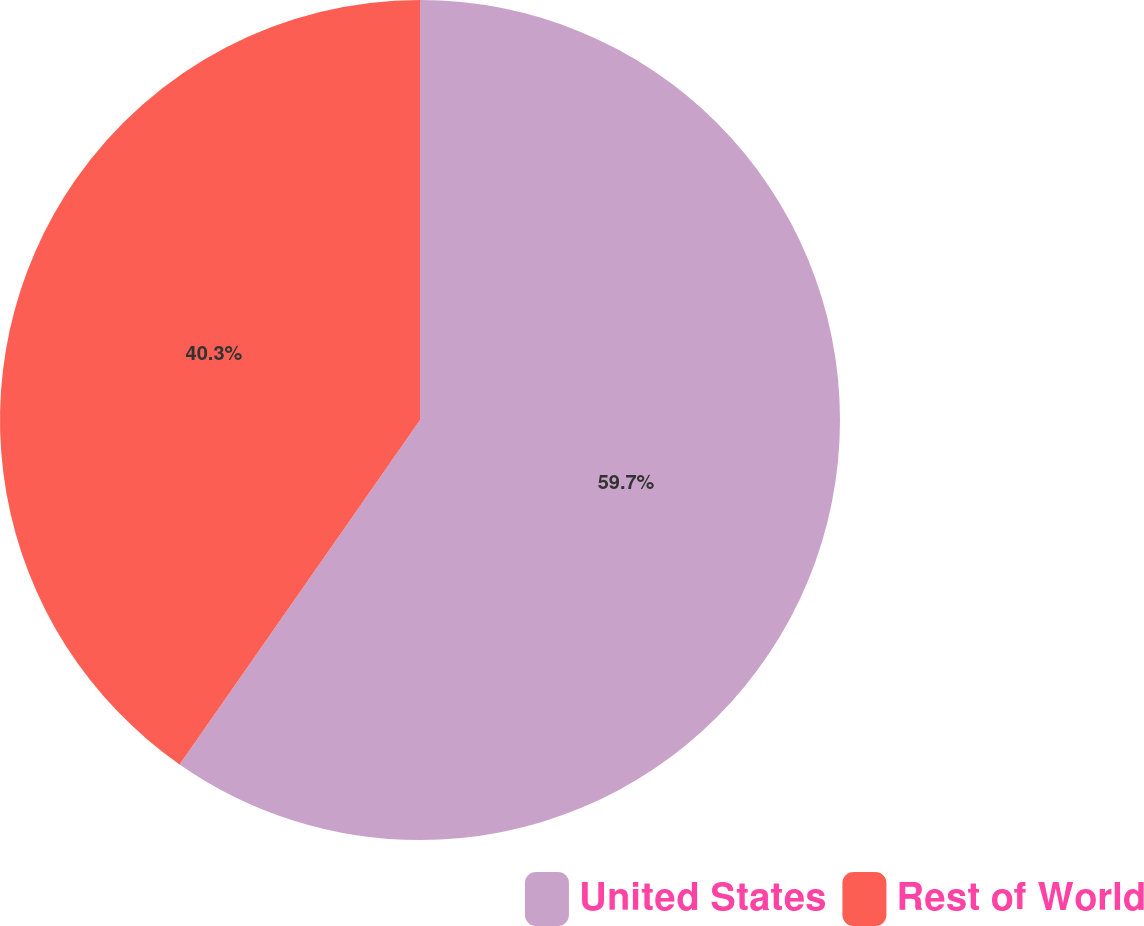<chart> <loc_0><loc_0><loc_500><loc_500><pie_chart><fcel>United States<fcel>Rest of World<nl><fcel>59.7%<fcel>40.3%<nl></chart> 